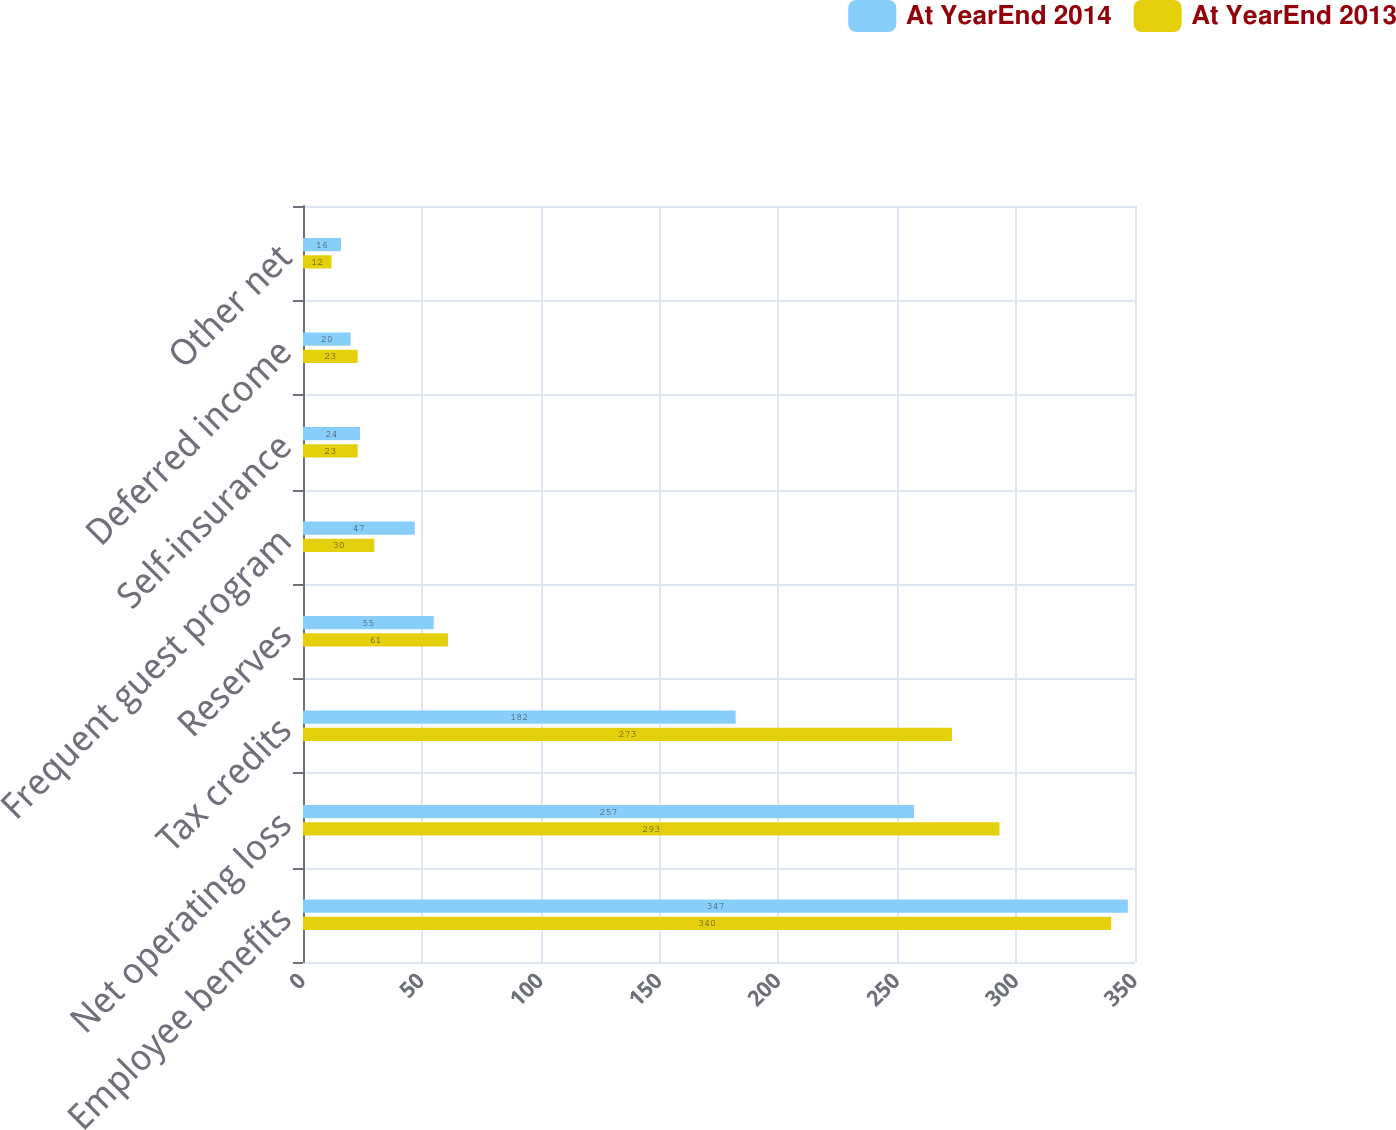Convert chart to OTSL. <chart><loc_0><loc_0><loc_500><loc_500><stacked_bar_chart><ecel><fcel>Employee benefits<fcel>Net operating loss<fcel>Tax credits<fcel>Reserves<fcel>Frequent guest program<fcel>Self-insurance<fcel>Deferred income<fcel>Other net<nl><fcel>At YearEnd 2014<fcel>347<fcel>257<fcel>182<fcel>55<fcel>47<fcel>24<fcel>20<fcel>16<nl><fcel>At YearEnd 2013<fcel>340<fcel>293<fcel>273<fcel>61<fcel>30<fcel>23<fcel>23<fcel>12<nl></chart> 